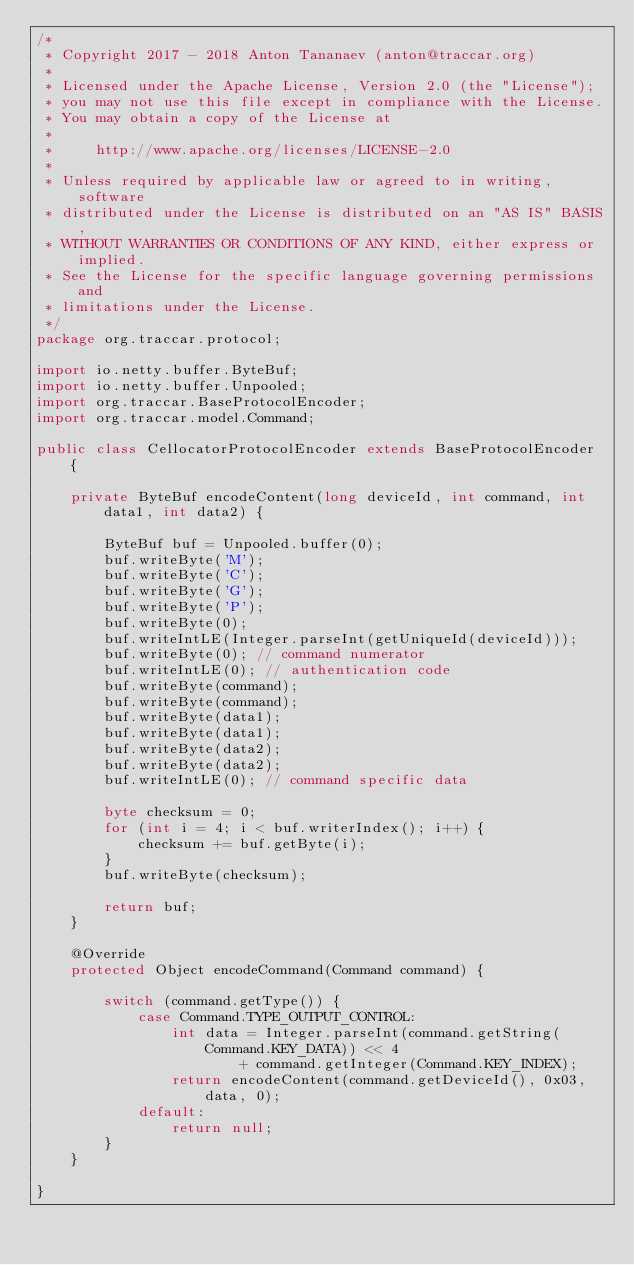Convert code to text. <code><loc_0><loc_0><loc_500><loc_500><_Java_>/*
 * Copyright 2017 - 2018 Anton Tananaev (anton@traccar.org)
 *
 * Licensed under the Apache License, Version 2.0 (the "License");
 * you may not use this file except in compliance with the License.
 * You may obtain a copy of the License at
 *
 *     http://www.apache.org/licenses/LICENSE-2.0
 *
 * Unless required by applicable law or agreed to in writing, software
 * distributed under the License is distributed on an "AS IS" BASIS,
 * WITHOUT WARRANTIES OR CONDITIONS OF ANY KIND, either express or implied.
 * See the License for the specific language governing permissions and
 * limitations under the License.
 */
package org.traccar.protocol;

import io.netty.buffer.ByteBuf;
import io.netty.buffer.Unpooled;
import org.traccar.BaseProtocolEncoder;
import org.traccar.model.Command;

public class CellocatorProtocolEncoder extends BaseProtocolEncoder {

    private ByteBuf encodeContent(long deviceId, int command, int data1, int data2) {

        ByteBuf buf = Unpooled.buffer(0);
        buf.writeByte('M');
        buf.writeByte('C');
        buf.writeByte('G');
        buf.writeByte('P');
        buf.writeByte(0);
        buf.writeIntLE(Integer.parseInt(getUniqueId(deviceId)));
        buf.writeByte(0); // command numerator
        buf.writeIntLE(0); // authentication code
        buf.writeByte(command);
        buf.writeByte(command);
        buf.writeByte(data1);
        buf.writeByte(data1);
        buf.writeByte(data2);
        buf.writeByte(data2);
        buf.writeIntLE(0); // command specific data

        byte checksum = 0;
        for (int i = 4; i < buf.writerIndex(); i++) {
            checksum += buf.getByte(i);
        }
        buf.writeByte(checksum);

        return buf;
    }

    @Override
    protected Object encodeCommand(Command command) {

        switch (command.getType()) {
            case Command.TYPE_OUTPUT_CONTROL:
                int data = Integer.parseInt(command.getString(Command.KEY_DATA)) << 4
                        + command.getInteger(Command.KEY_INDEX);
                return encodeContent(command.getDeviceId(), 0x03, data, 0);
            default:
                return null;
        }
    }

}
</code> 